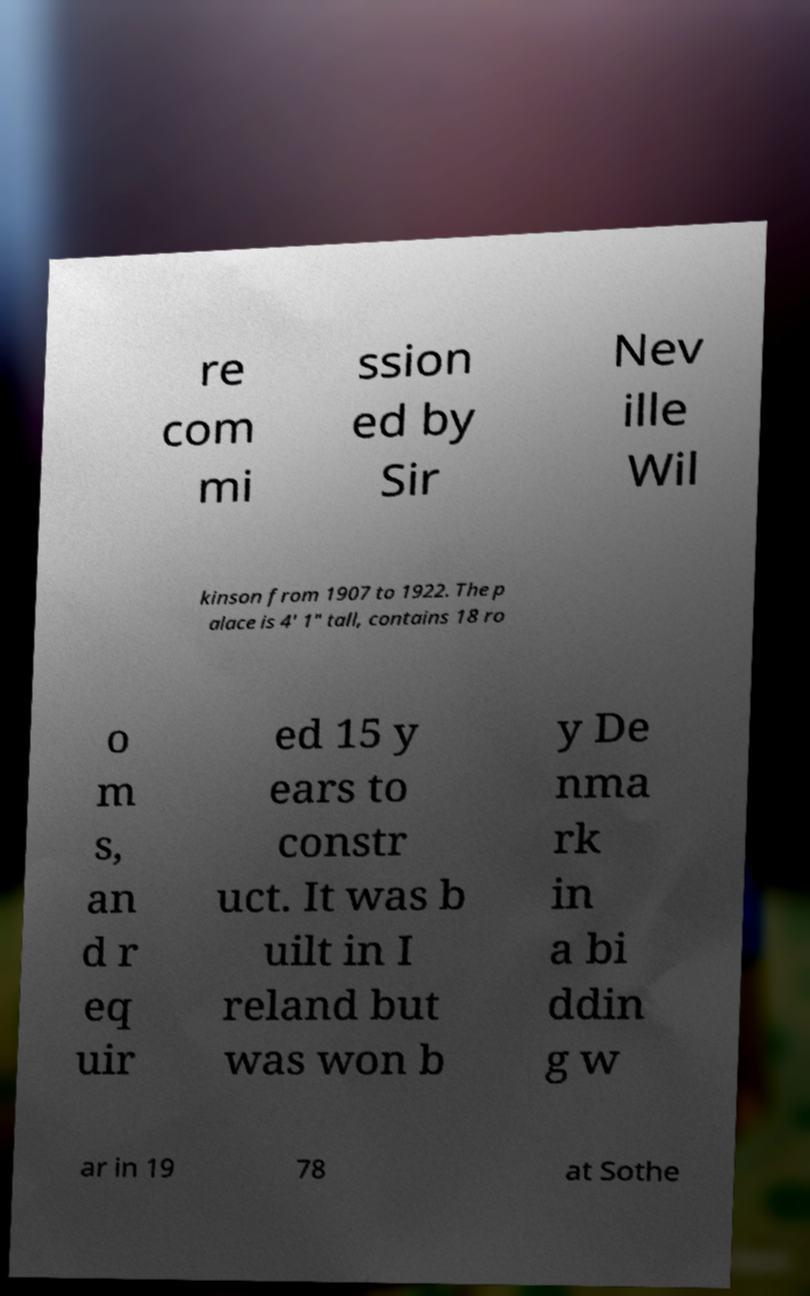Can you accurately transcribe the text from the provided image for me? re com mi ssion ed by Sir Nev ille Wil kinson from 1907 to 1922. The p alace is 4' 1" tall, contains 18 ro o m s, an d r eq uir ed 15 y ears to constr uct. It was b uilt in I reland but was won b y De nma rk in a bi ddin g w ar in 19 78 at Sothe 